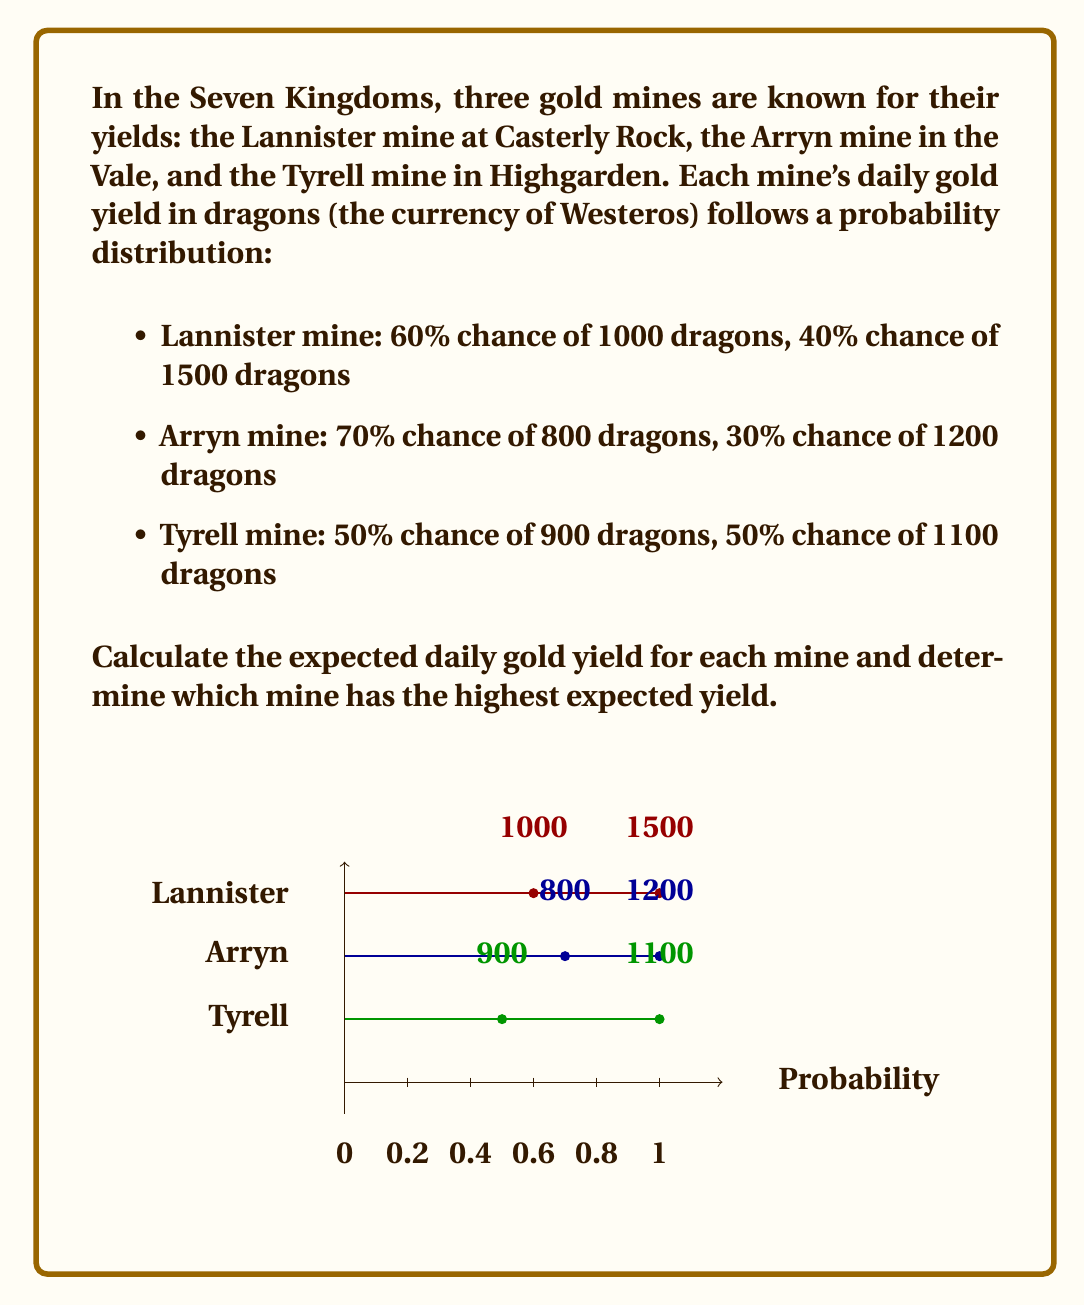Could you help me with this problem? To solve this problem, we need to calculate the expected value for each mine's daily gold yield. The expected value is the sum of each possible outcome multiplied by its probability.

1. Lannister mine:
   $E(L) = 1000 \cdot 0.60 + 1500 \cdot 0.40$
   $E(L) = 600 + 600 = 1200$ dragons

2. Arryn mine:
   $E(A) = 800 \cdot 0.70 + 1200 \cdot 0.30$
   $E(A) = 560 + 360 = 920$ dragons

3. Tyrell mine:
   $E(T) = 900 \cdot 0.50 + 1100 \cdot 0.50$
   $E(T) = 450 + 550 = 1000$ dragons

Now, we compare the expected values:
$E(L) = 1200 > E(T) = 1000 > E(A) = 920$

Therefore, the Lannister mine has the highest expected daily gold yield at 1200 dragons.
Answer: Lannister mine: 1200 dragons 